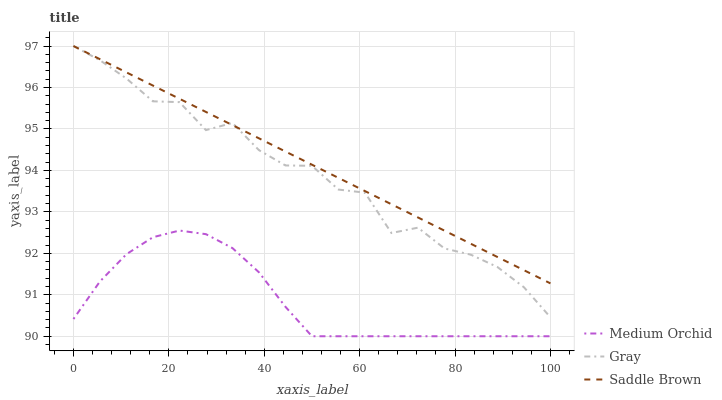Does Medium Orchid have the minimum area under the curve?
Answer yes or no. Yes. Does Saddle Brown have the maximum area under the curve?
Answer yes or no. Yes. Does Saddle Brown have the minimum area under the curve?
Answer yes or no. No. Does Medium Orchid have the maximum area under the curve?
Answer yes or no. No. Is Saddle Brown the smoothest?
Answer yes or no. Yes. Is Gray the roughest?
Answer yes or no. Yes. Is Medium Orchid the smoothest?
Answer yes or no. No. Is Medium Orchid the roughest?
Answer yes or no. No. Does Medium Orchid have the lowest value?
Answer yes or no. Yes. Does Saddle Brown have the lowest value?
Answer yes or no. No. Does Saddle Brown have the highest value?
Answer yes or no. Yes. Does Medium Orchid have the highest value?
Answer yes or no. No. Is Medium Orchid less than Gray?
Answer yes or no. Yes. Is Saddle Brown greater than Medium Orchid?
Answer yes or no. Yes. Does Gray intersect Saddle Brown?
Answer yes or no. Yes. Is Gray less than Saddle Brown?
Answer yes or no. No. Is Gray greater than Saddle Brown?
Answer yes or no. No. Does Medium Orchid intersect Gray?
Answer yes or no. No. 